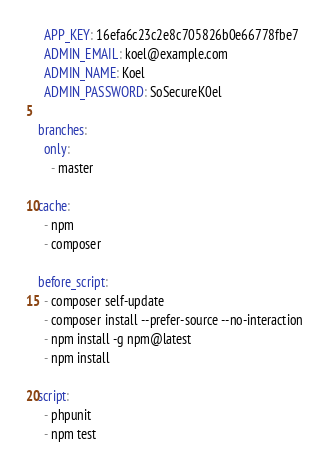<code> <loc_0><loc_0><loc_500><loc_500><_YAML_>  APP_KEY: 16efa6c23c2e8c705826b0e66778fbe7
  ADMIN_EMAIL: koel@example.com
  ADMIN_NAME: Koel
  ADMIN_PASSWORD: SoSecureK0el

branches:
  only:
    - master

cache:
  - npm
  - composer

before_script:
  - composer self-update
  - composer install --prefer-source --no-interaction
  - npm install -g npm@latest
  - npm install    

script: 
  - phpunit
  - npm test
</code> 